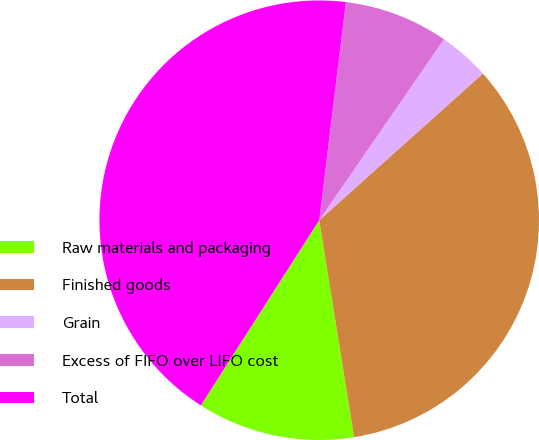Convert chart to OTSL. <chart><loc_0><loc_0><loc_500><loc_500><pie_chart><fcel>Raw materials and packaging<fcel>Finished goods<fcel>Grain<fcel>Excess of FIFO over LIFO cost<fcel>Total<nl><fcel>11.59%<fcel>34.09%<fcel>3.76%<fcel>7.67%<fcel>42.88%<nl></chart> 